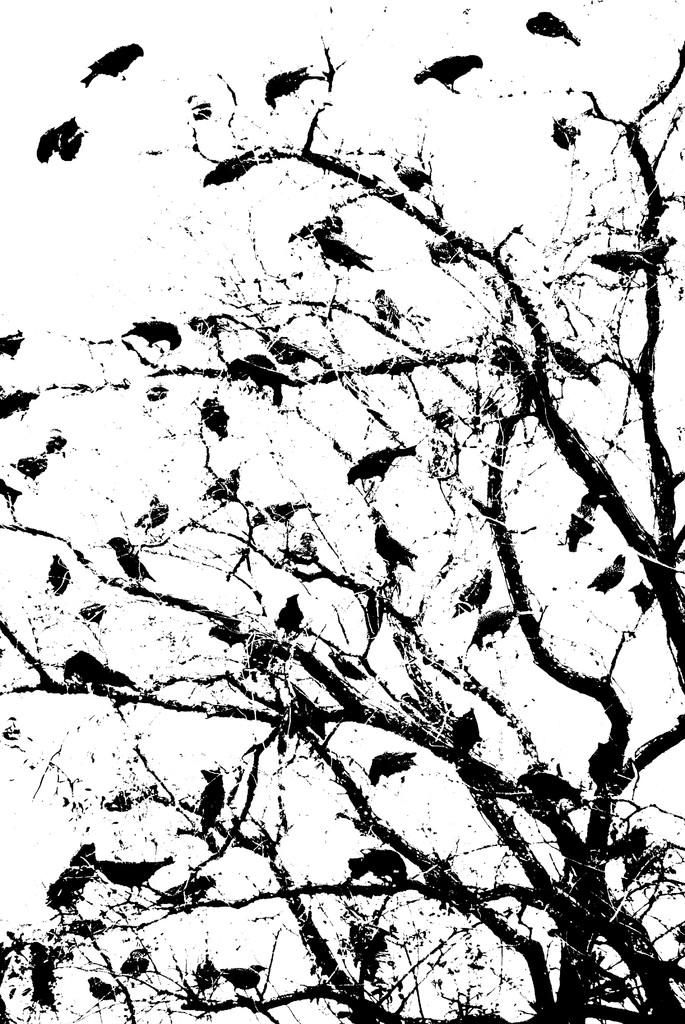What type of image is being shown? The image is an edited picture. What can be seen in the image besides the editing? There are birds present in the image. Where are the birds located? The birds are present on a tree. What type of bean is being used to control the birds in the image? There is no bean present in the image, and the birds are not being controlled by any means. 